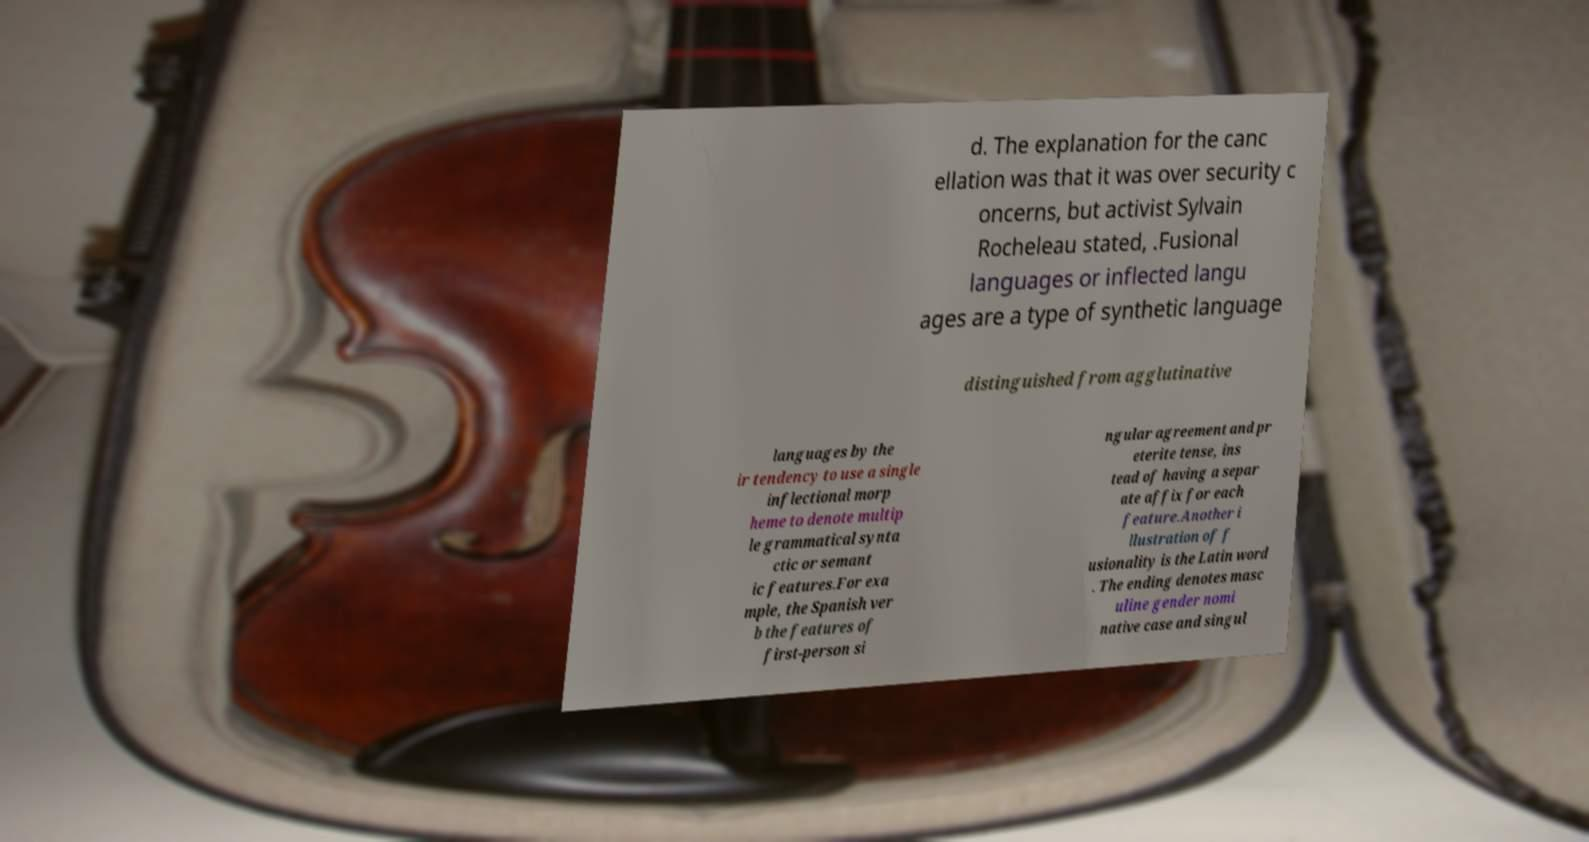For documentation purposes, I need the text within this image transcribed. Could you provide that? d. The explanation for the canc ellation was that it was over security c oncerns, but activist Sylvain Rocheleau stated, .Fusional languages or inflected langu ages are a type of synthetic language distinguished from agglutinative languages by the ir tendency to use a single inflectional morp heme to denote multip le grammatical synta ctic or semant ic features.For exa mple, the Spanish ver b the features of first-person si ngular agreement and pr eterite tense, ins tead of having a separ ate affix for each feature.Another i llustration of f usionality is the Latin word . The ending denotes masc uline gender nomi native case and singul 